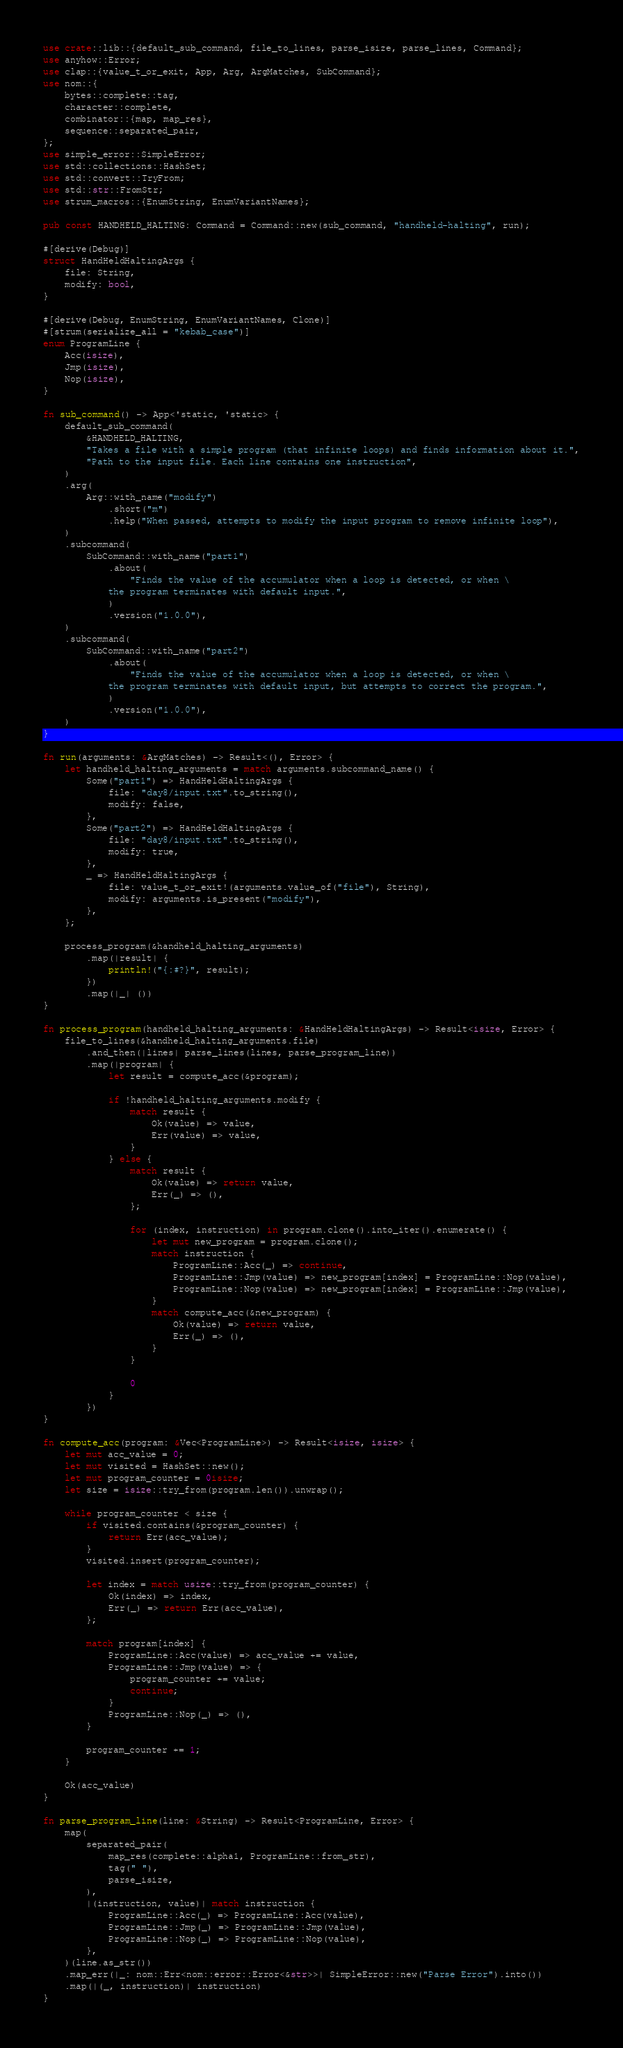Convert code to text. <code><loc_0><loc_0><loc_500><loc_500><_Rust_>use crate::lib::{default_sub_command, file_to_lines, parse_isize, parse_lines, Command};
use anyhow::Error;
use clap::{value_t_or_exit, App, Arg, ArgMatches, SubCommand};
use nom::{
    bytes::complete::tag,
    character::complete,
    combinator::{map, map_res},
    sequence::separated_pair,
};
use simple_error::SimpleError;
use std::collections::HashSet;
use std::convert::TryFrom;
use std::str::FromStr;
use strum_macros::{EnumString, EnumVariantNames};

pub const HANDHELD_HALTING: Command = Command::new(sub_command, "handheld-halting", run);

#[derive(Debug)]
struct HandHeldHaltingArgs {
    file: String,
    modify: bool,
}

#[derive(Debug, EnumString, EnumVariantNames, Clone)]
#[strum(serialize_all = "kebab_case")]
enum ProgramLine {
    Acc(isize),
    Jmp(isize),
    Nop(isize),
}

fn sub_command() -> App<'static, 'static> {
    default_sub_command(
        &HANDHELD_HALTING,
        "Takes a file with a simple program (that infinite loops) and finds information about it.",
        "Path to the input file. Each line contains one instruction",
    )
    .arg(
        Arg::with_name("modify")
            .short("m")
            .help("When passed, attempts to modify the input program to remove infinite loop"),
    )
    .subcommand(
        SubCommand::with_name("part1")
            .about(
                "Finds the value of the accumulator when a loop is detected, or when \
            the program terminates with default input.",
            )
            .version("1.0.0"),
    )
    .subcommand(
        SubCommand::with_name("part2")
            .about(
                "Finds the value of the accumulator when a loop is detected, or when \
            the program terminates with default input, but attempts to correct the program.",
            )
            .version("1.0.0"),
    )
}

fn run(arguments: &ArgMatches) -> Result<(), Error> {
    let handheld_halting_arguments = match arguments.subcommand_name() {
        Some("part1") => HandHeldHaltingArgs {
            file: "day8/input.txt".to_string(),
            modify: false,
        },
        Some("part2") => HandHeldHaltingArgs {
            file: "day8/input.txt".to_string(),
            modify: true,
        },
        _ => HandHeldHaltingArgs {
            file: value_t_or_exit!(arguments.value_of("file"), String),
            modify: arguments.is_present("modify"),
        },
    };

    process_program(&handheld_halting_arguments)
        .map(|result| {
            println!("{:#?}", result);
        })
        .map(|_| ())
}

fn process_program(handheld_halting_arguments: &HandHeldHaltingArgs) -> Result<isize, Error> {
    file_to_lines(&handheld_halting_arguments.file)
        .and_then(|lines| parse_lines(lines, parse_program_line))
        .map(|program| {
            let result = compute_acc(&program);

            if !handheld_halting_arguments.modify {
                match result {
                    Ok(value) => value,
                    Err(value) => value,
                }
            } else {
                match result {
                    Ok(value) => return value,
                    Err(_) => (),
                };

                for (index, instruction) in program.clone().into_iter().enumerate() {
                    let mut new_program = program.clone();
                    match instruction {
                        ProgramLine::Acc(_) => continue,
                        ProgramLine::Jmp(value) => new_program[index] = ProgramLine::Nop(value),
                        ProgramLine::Nop(value) => new_program[index] = ProgramLine::Jmp(value),
                    }
                    match compute_acc(&new_program) {
                        Ok(value) => return value,
                        Err(_) => (),
                    }
                }

                0
            }
        })
}

fn compute_acc(program: &Vec<ProgramLine>) -> Result<isize, isize> {
    let mut acc_value = 0;
    let mut visited = HashSet::new();
    let mut program_counter = 0isize;
    let size = isize::try_from(program.len()).unwrap();

    while program_counter < size {
        if visited.contains(&program_counter) {
            return Err(acc_value);
        }
        visited.insert(program_counter);

        let index = match usize::try_from(program_counter) {
            Ok(index) => index,
            Err(_) => return Err(acc_value),
        };

        match program[index] {
            ProgramLine::Acc(value) => acc_value += value,
            ProgramLine::Jmp(value) => {
                program_counter += value;
                continue;
            }
            ProgramLine::Nop(_) => (),
        }

        program_counter += 1;
    }

    Ok(acc_value)
}

fn parse_program_line(line: &String) -> Result<ProgramLine, Error> {
    map(
        separated_pair(
            map_res(complete::alpha1, ProgramLine::from_str),
            tag(" "),
            parse_isize,
        ),
        |(instruction, value)| match instruction {
            ProgramLine::Acc(_) => ProgramLine::Acc(value),
            ProgramLine::Jmp(_) => ProgramLine::Jmp(value),
            ProgramLine::Nop(_) => ProgramLine::Nop(value),
        },
    )(line.as_str())
    .map_err(|_: nom::Err<nom::error::Error<&str>>| SimpleError::new("Parse Error").into())
    .map(|(_, instruction)| instruction)
}
</code> 